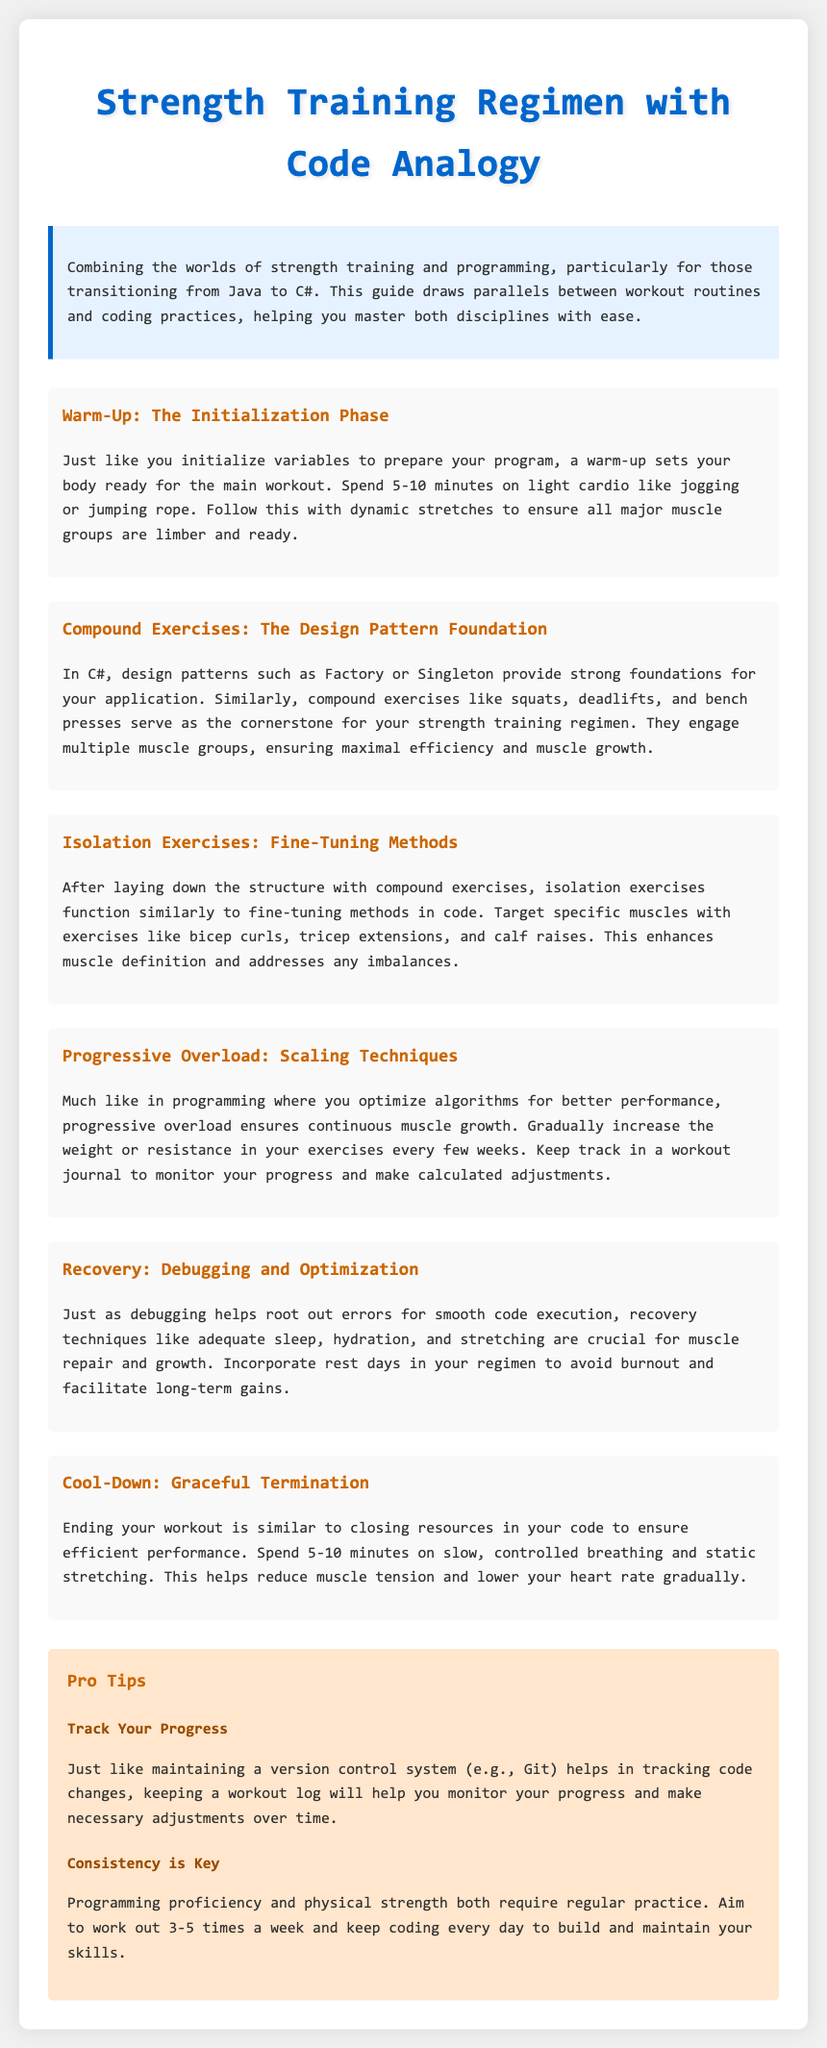What is the title of the document? The title is displayed prominently at the top of the document.
Answer: Strength Training Regimen with Code Analogy How long should the warm-up last? The document specifies the duration of the warm-up in the corresponding section.
Answer: 5-10 minutes What type of exercises are squats, deadlifts, and bench presses classified as? This information can be found under the section about compound exercises.
Answer: Compound exercises What does progressive overload relate to in programming? The document draws an analogy between progressive overload and a concept in programming regarding performance.
Answer: Scaling techniques What is the main purpose of the cool-down phase? The document mentions the focus of the cool-down phase, which relates to body management after workouts.
Answer: Graceful termination What should be included in a workout log? The document highlights the importance of tracking elements in a workout log for effective progress monitoring.
Answer: Progress How many times per week should one aim to work out? The ideal frequency for workouts is mentioned as a recommendation in the tips section.
Answer: 3-5 times a week 